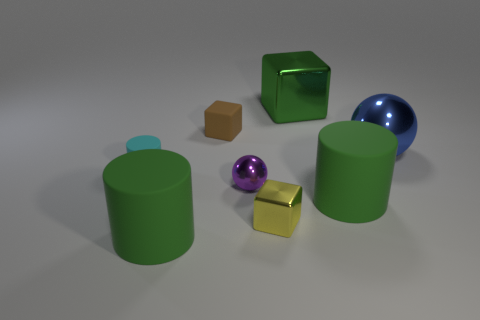Are any of the objects casting shadows, and what does this tell us about the light source? Each object casts a soft shadow on the ground, indicating a diffused light source coming from the upper left, which might suggest an ambient lighting environment rather than a direct spotlight. 